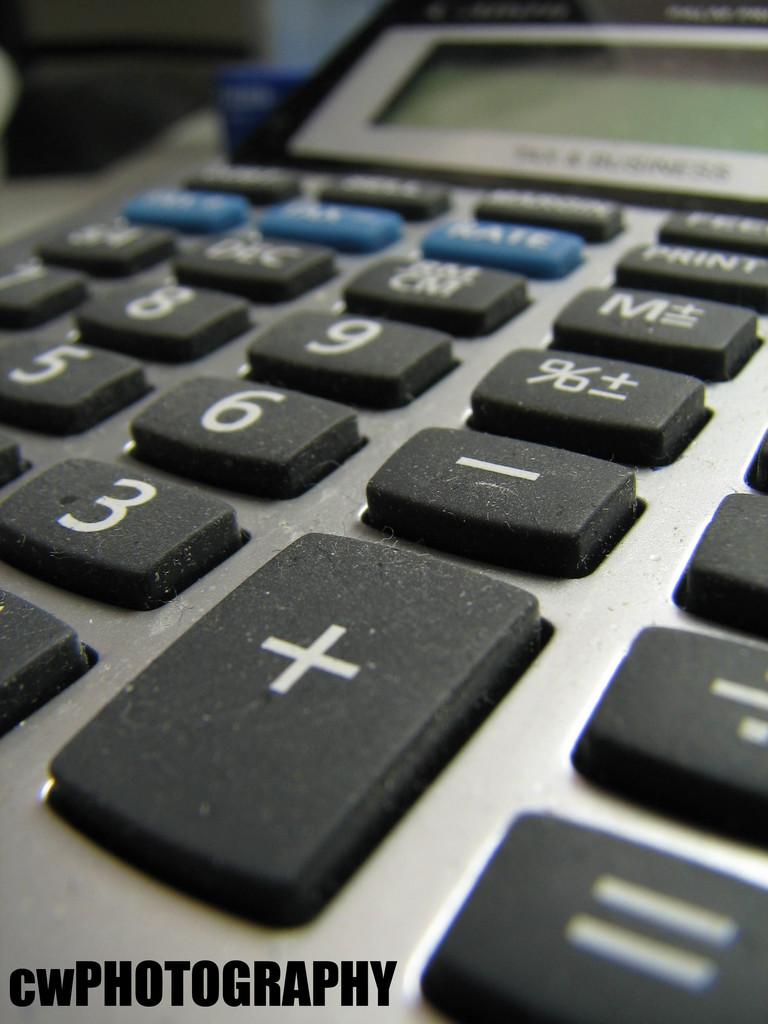What is the top right number?
Offer a terse response. 9. 